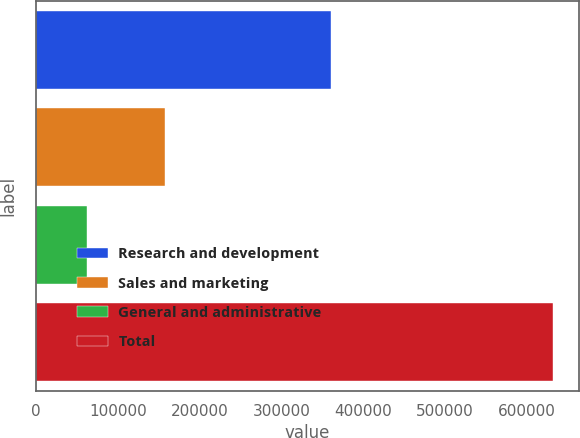Convert chart. <chart><loc_0><loc_0><loc_500><loc_500><bar_chart><fcel>Research and development<fcel>Sales and marketing<fcel>General and administrative<fcel>Total<nl><fcel>360726<fcel>157263<fcel>63072<fcel>631597<nl></chart> 